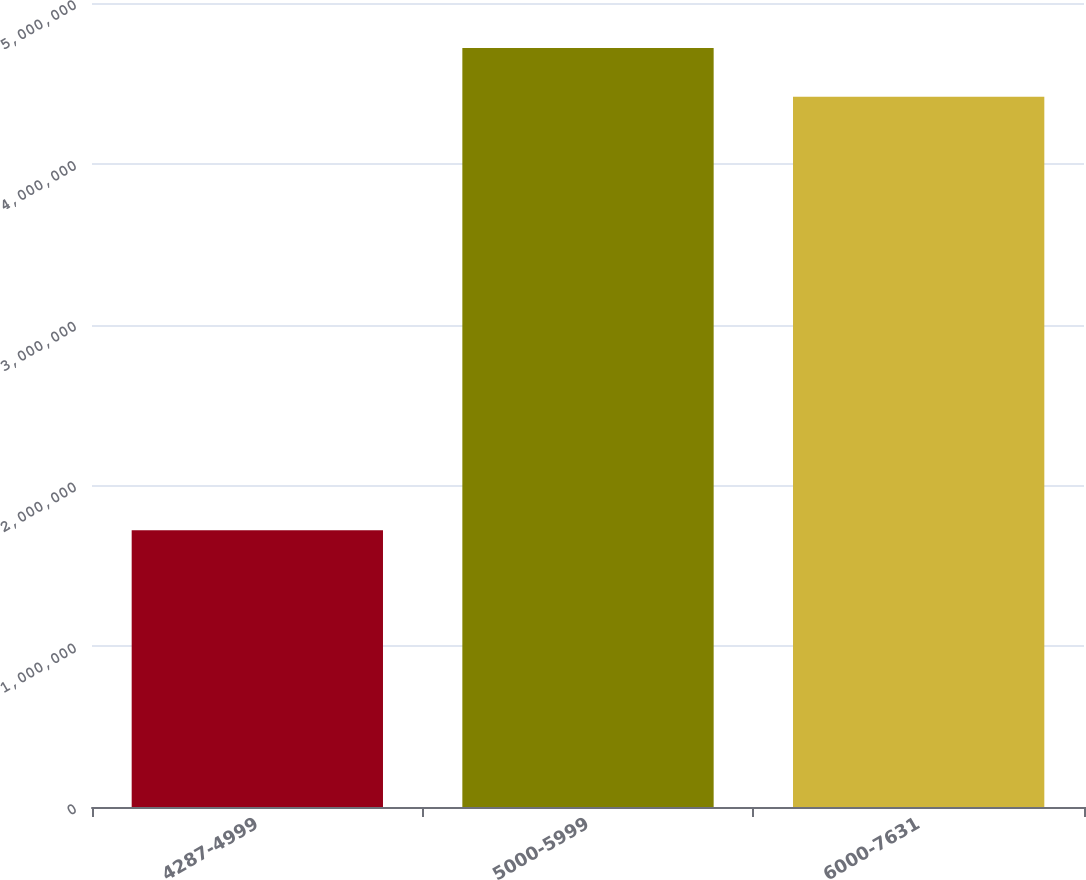Convert chart. <chart><loc_0><loc_0><loc_500><loc_500><bar_chart><fcel>4287-4999<fcel>5000-5999<fcel>6000-7631<nl><fcel>1.72144e+06<fcel>4.72092e+06<fcel>4.41676e+06<nl></chart> 